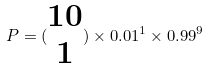<formula> <loc_0><loc_0><loc_500><loc_500>P = ( \begin{matrix} 1 0 \\ 1 \end{matrix} ) \times 0 . 0 1 ^ { 1 } \times 0 . 9 9 ^ { 9 }</formula> 